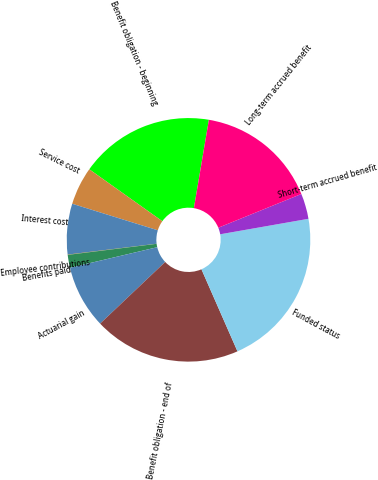<chart> <loc_0><loc_0><loc_500><loc_500><pie_chart><fcel>Benefit obligation - beginning<fcel>Service cost<fcel>Interest cost<fcel>Employee contributions<fcel>Benefits paid<fcel>Actuarial gain<fcel>Benefit obligation - end of<fcel>Funded status<fcel>Short-term accrued benefit<fcel>Long-term accrued benefit<nl><fcel>17.84%<fcel>5.05%<fcel>6.72%<fcel>0.04%<fcel>1.71%<fcel>8.39%<fcel>19.51%<fcel>21.18%<fcel>3.38%<fcel>16.18%<nl></chart> 